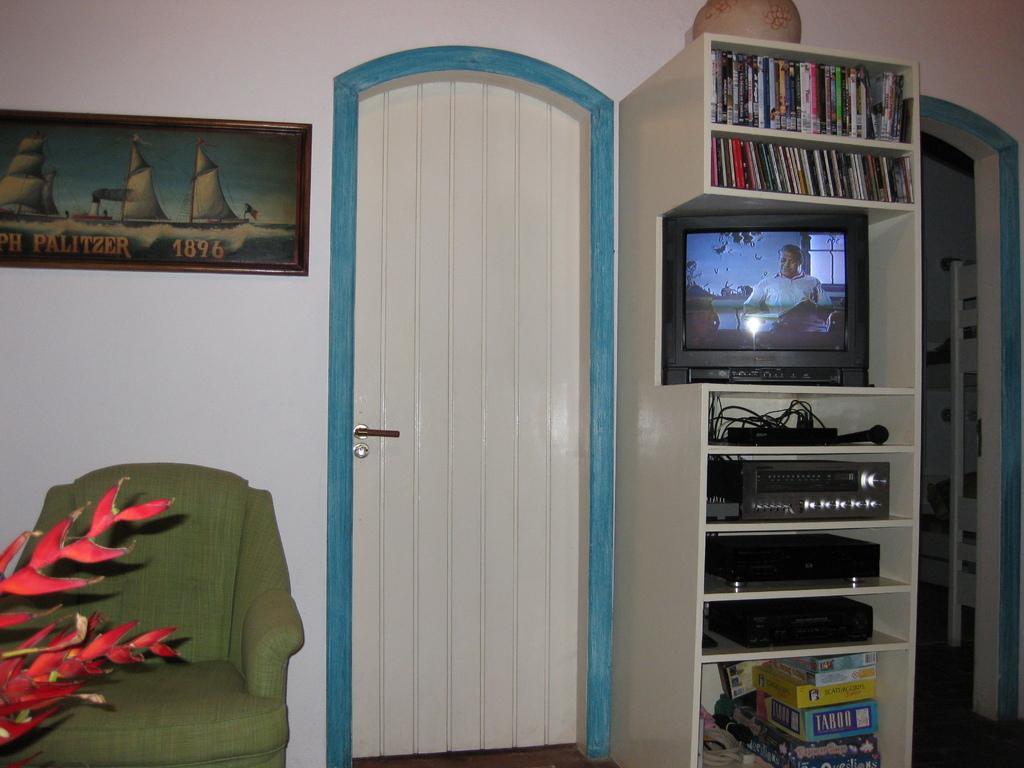How would you summarize this image in a sentence or two? This is the picture of a room. On the left side of the image there is a plant and there is a chair and there is a door and there is frame on the wall. On the right side of the image there are books and there is a television and there are boxes and there are devices and there is a microphone in the shelf and there is an object on the shelf. At the bottom there is a floor. 